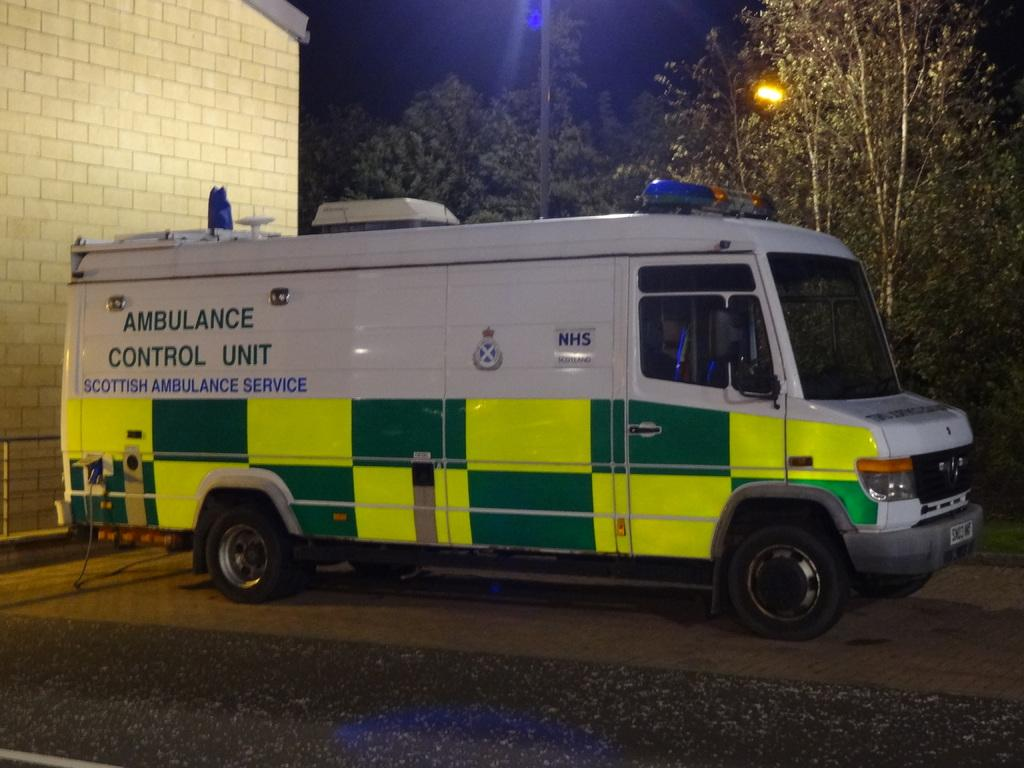What is the main subject of the image? The main subject of the image is an ambulance. Can you describe the color of the ambulance? The ambulance is white. What structure can be seen on the left side of the image? There is a hospital on the left side of the image. What type of natural elements are present in the middle of the image? There are trees in the middle of the image. What type of meal is being served to the queen in the image? There is no queen or meal present in the image; it features an ambulance and a hospital. What type of border surrounds the image? The provided facts do not mention any borders surrounding the image. 